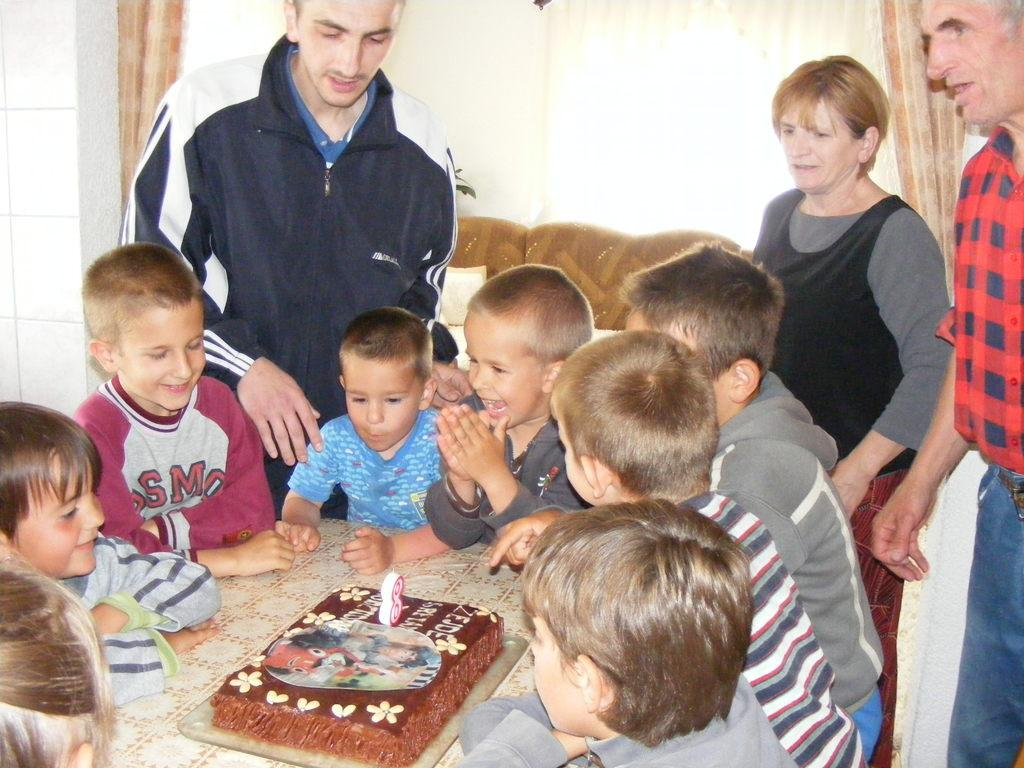What are the children doing in the image? The children are sitting around a table in the image. What is on the table with the children? There is a cake on the table. How many people are standing on the floor in the image? There are three persons standing on the floor in the image. What can be seen behind the children and the table? There is a wall visible in the image. What type of mass is being discussed by the children in the image? There is no indication in the image that the children are discussing any type of mass. 